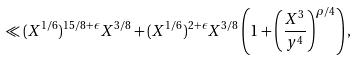Convert formula to latex. <formula><loc_0><loc_0><loc_500><loc_500>\ll ( X ^ { 1 / 6 } ) ^ { 1 5 / 8 + \epsilon } X ^ { 3 / 8 } + ( X ^ { 1 / 6 } ) ^ { 2 + \epsilon } X ^ { 3 / 8 } \left ( 1 + \left ( \frac { X ^ { 3 } } { y ^ { 4 } } \right ) ^ { \rho / 4 } \right ) ,</formula> 